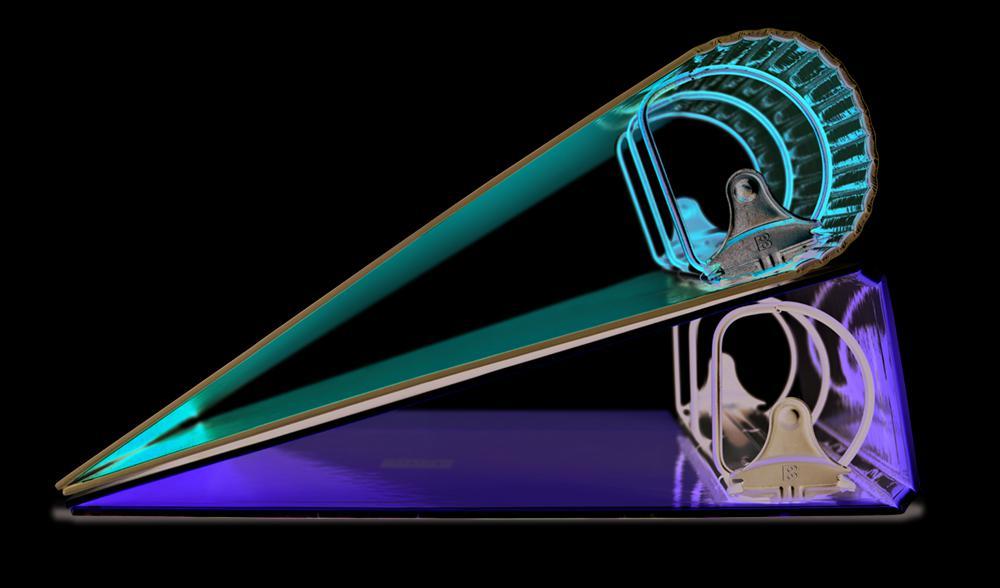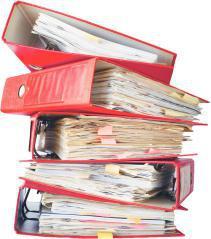The first image is the image on the left, the second image is the image on the right. Analyze the images presented: Is the assertion "There are stacks of binders with orange mixed with black" valid? Answer yes or no. No. The first image is the image on the left, the second image is the image on the right. Examine the images to the left and right. Is the description "Multiple black and orange binders are stacked on top of one another" accurate? Answer yes or no. No. 